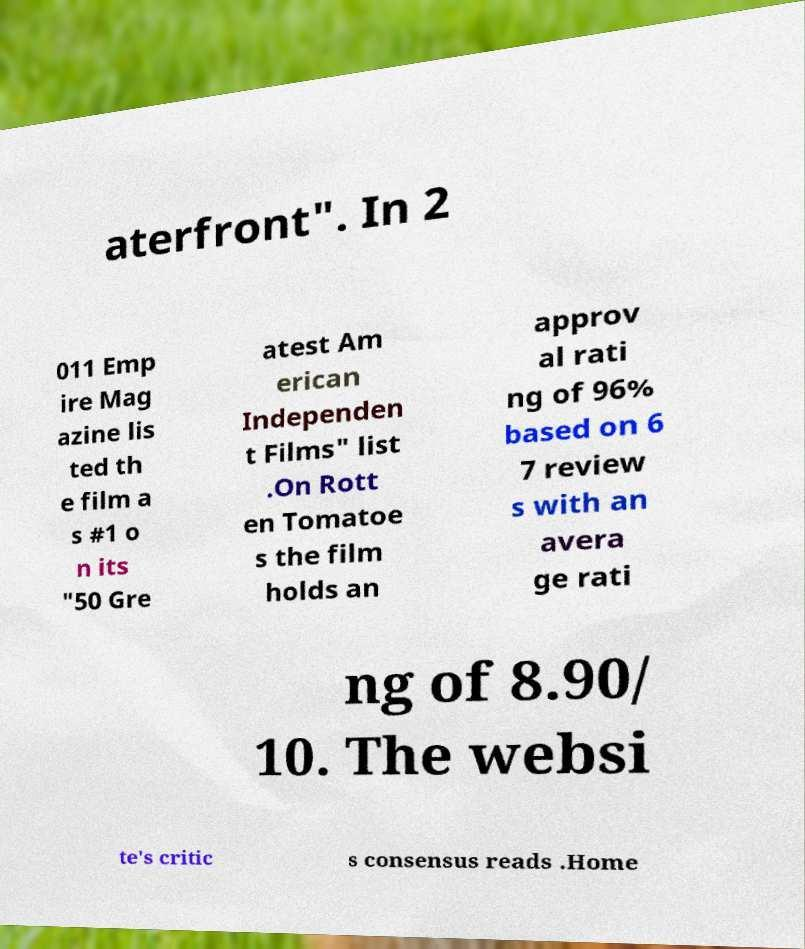Can you read and provide the text displayed in the image?This photo seems to have some interesting text. Can you extract and type it out for me? aterfront". In 2 011 Emp ire Mag azine lis ted th e film a s #1 o n its "50 Gre atest Am erican Independen t Films" list .On Rott en Tomatoe s the film holds an approv al rati ng of 96% based on 6 7 review s with an avera ge rati ng of 8.90/ 10. The websi te's critic s consensus reads .Home 